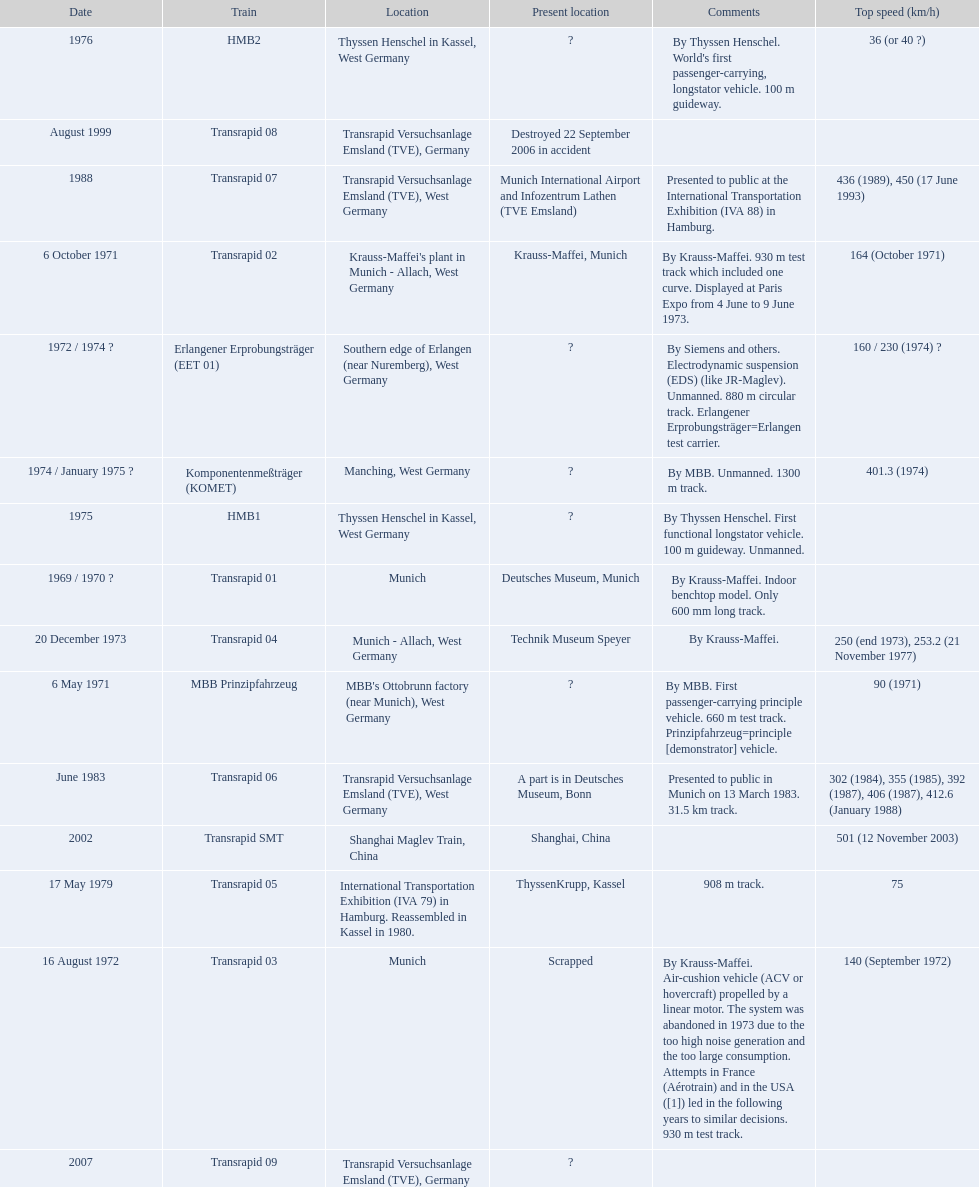How many trains listed have the same speed as the hmb2? 0. Would you be able to parse every entry in this table? {'header': ['Date', 'Train', 'Location', 'Present location', 'Comments', 'Top speed (km/h)'], 'rows': [['1976', 'HMB2', 'Thyssen Henschel in Kassel, West Germany', '?', "By Thyssen Henschel. World's first passenger-carrying, longstator vehicle. 100 m guideway.", '36 (or 40\xa0?)'], ['August 1999', 'Transrapid 08', 'Transrapid Versuchsanlage Emsland (TVE), Germany', 'Destroyed 22 September 2006 in accident', '', ''], ['1988', 'Transrapid 07', 'Transrapid Versuchsanlage Emsland (TVE), West Germany', 'Munich International Airport and Infozentrum Lathen (TVE Emsland)', 'Presented to public at the International Transportation Exhibition (IVA 88) in Hamburg.', '436 (1989), 450 (17 June 1993)'], ['6 October 1971', 'Transrapid 02', "Krauss-Maffei's plant in Munich - Allach, West Germany", 'Krauss-Maffei, Munich', 'By Krauss-Maffei. 930 m test track which included one curve. Displayed at Paris Expo from 4 June to 9 June 1973.', '164 (October 1971)'], ['1972 / 1974\xa0?', 'Erlangener Erprobungsträger (EET 01)', 'Southern edge of Erlangen (near Nuremberg), West Germany', '?', 'By Siemens and others. Electrodynamic suspension (EDS) (like JR-Maglev). Unmanned. 880 m circular track. Erlangener Erprobungsträger=Erlangen test carrier.', '160 / 230 (1974)\xa0?'], ['1974 / January 1975\xa0?', 'Komponentenmeßträger (KOMET)', 'Manching, West Germany', '?', 'By MBB. Unmanned. 1300 m track.', '401.3 (1974)'], ['1975', 'HMB1', 'Thyssen Henschel in Kassel, West Germany', '?', 'By Thyssen Henschel. First functional longstator vehicle. 100 m guideway. Unmanned.', ''], ['1969 / 1970\xa0?', 'Transrapid 01', 'Munich', 'Deutsches Museum, Munich', 'By Krauss-Maffei. Indoor benchtop model. Only 600\xa0mm long track.', ''], ['20 December 1973', 'Transrapid 04', 'Munich - Allach, West Germany', 'Technik Museum Speyer', 'By Krauss-Maffei.', '250 (end 1973), 253.2 (21 November 1977)'], ['6 May 1971', 'MBB Prinzipfahrzeug', "MBB's Ottobrunn factory (near Munich), West Germany", '?', 'By MBB. First passenger-carrying principle vehicle. 660 m test track. Prinzipfahrzeug=principle [demonstrator] vehicle.', '90 (1971)'], ['June 1983', 'Transrapid 06', 'Transrapid Versuchsanlage Emsland (TVE), West Germany', 'A part is in Deutsches Museum, Bonn', 'Presented to public in Munich on 13 March 1983. 31.5\xa0km track.', '302 (1984), 355 (1985), 392 (1987), 406 (1987), 412.6 (January 1988)'], ['2002', 'Transrapid SMT', 'Shanghai Maglev Train, China', 'Shanghai, China', '', '501 (12 November 2003)'], ['17 May 1979', 'Transrapid 05', 'International Transportation Exhibition (IVA 79) in Hamburg. Reassembled in Kassel in 1980.', 'ThyssenKrupp, Kassel', '908 m track.', '75'], ['16 August 1972', 'Transrapid 03', 'Munich', 'Scrapped', 'By Krauss-Maffei. Air-cushion vehicle (ACV or hovercraft) propelled by a linear motor. The system was abandoned in 1973 due to the too high noise generation and the too large consumption. Attempts in France (Aérotrain) and in the USA ([1]) led in the following years to similar decisions. 930 m test track.', '140 (September 1972)'], ['2007', 'Transrapid 09', 'Transrapid Versuchsanlage Emsland (TVE), Germany', '?', '', '']]} 